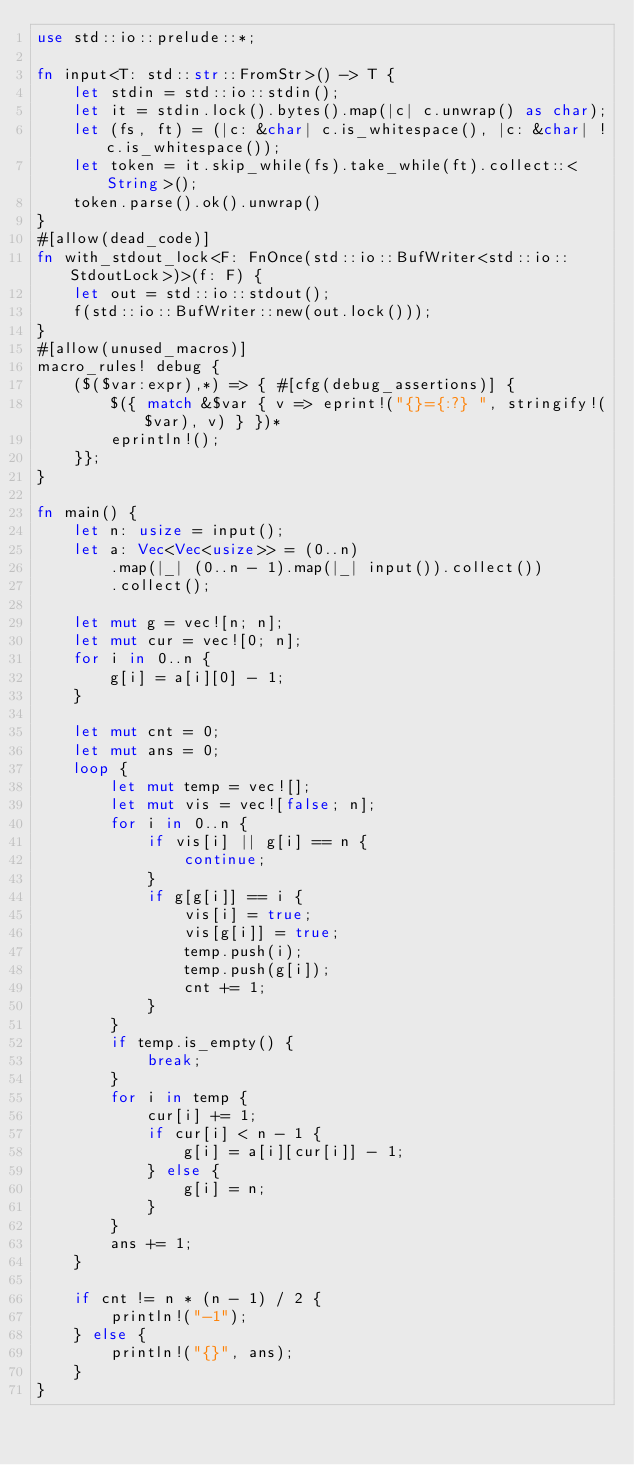Convert code to text. <code><loc_0><loc_0><loc_500><loc_500><_Rust_>use std::io::prelude::*;

fn input<T: std::str::FromStr>() -> T {
    let stdin = std::io::stdin();
    let it = stdin.lock().bytes().map(|c| c.unwrap() as char);
    let (fs, ft) = (|c: &char| c.is_whitespace(), |c: &char| !c.is_whitespace());
    let token = it.skip_while(fs).take_while(ft).collect::<String>();
    token.parse().ok().unwrap()
}
#[allow(dead_code)]
fn with_stdout_lock<F: FnOnce(std::io::BufWriter<std::io::StdoutLock>)>(f: F) {
    let out = std::io::stdout();
    f(std::io::BufWriter::new(out.lock()));
}
#[allow(unused_macros)]
macro_rules! debug {
    ($($var:expr),*) => { #[cfg(debug_assertions)] {
        $({ match &$var { v => eprint!("{}={:?} ", stringify!($var), v) } })*
        eprintln!();
    }};
}

fn main() {
    let n: usize = input();
    let a: Vec<Vec<usize>> = (0..n)
        .map(|_| (0..n - 1).map(|_| input()).collect())
        .collect();

    let mut g = vec![n; n];
    let mut cur = vec![0; n];
    for i in 0..n {
        g[i] = a[i][0] - 1;
    }

    let mut cnt = 0;
    let mut ans = 0;
    loop {
        let mut temp = vec![];
        let mut vis = vec![false; n];
        for i in 0..n {
            if vis[i] || g[i] == n {
                continue;
            }
            if g[g[i]] == i {
                vis[i] = true;
                vis[g[i]] = true;
                temp.push(i);
                temp.push(g[i]);
                cnt += 1;
            }
        }
        if temp.is_empty() {
            break;
        }
        for i in temp {
            cur[i] += 1;
            if cur[i] < n - 1 {
                g[i] = a[i][cur[i]] - 1;
            } else {
                g[i] = n;
            }
        }
        ans += 1;
    }

    if cnt != n * (n - 1) / 2 {
        println!("-1");
    } else {
        println!("{}", ans);
    }
}
</code> 